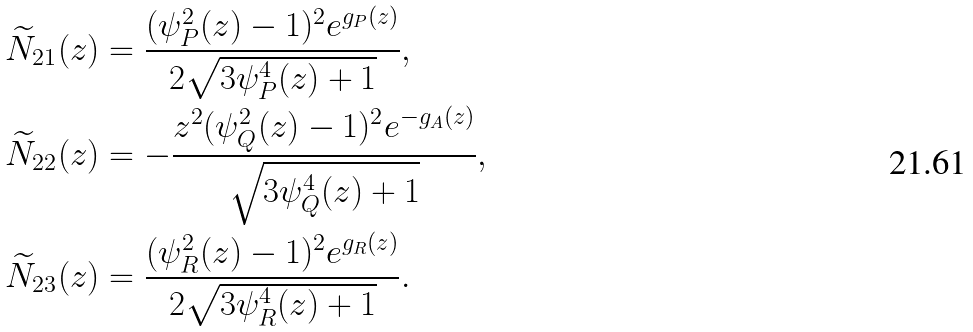Convert formula to latex. <formula><loc_0><loc_0><loc_500><loc_500>\widetilde { N } _ { 2 1 } ( z ) & = \frac { ( \psi _ { P } ^ { 2 } ( z ) - 1 ) ^ { 2 } e ^ { g _ { P } ( z ) } } { 2 \sqrt { 3 \psi _ { P } ^ { 4 } ( z ) + 1 } } , \\ \widetilde { N } _ { 2 2 } ( z ) & = - \frac { z ^ { 2 } ( \psi _ { Q } ^ { 2 } ( z ) - 1 ) ^ { 2 } e ^ { - g _ { A } ( z ) } } { \sqrt { 3 \psi _ { Q } ^ { 4 } ( z ) + 1 } } , \\ \widetilde { N } _ { 2 3 } ( z ) & = \frac { ( \psi _ { R } ^ { 2 } ( z ) - 1 ) ^ { 2 } e ^ { g _ { R } ( z ) } } { 2 \sqrt { 3 \psi _ { R } ^ { 4 } ( z ) + 1 } } .</formula> 